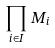Convert formula to latex. <formula><loc_0><loc_0><loc_500><loc_500>\prod _ { i \in I } M _ { i }</formula> 